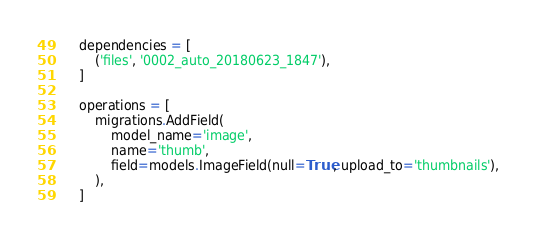Convert code to text. <code><loc_0><loc_0><loc_500><loc_500><_Python_>
    dependencies = [
        ('files', '0002_auto_20180623_1847'),
    ]

    operations = [
        migrations.AddField(
            model_name='image',
            name='thumb',
            field=models.ImageField(null=True, upload_to='thumbnails'),
        ),
    ]
</code> 